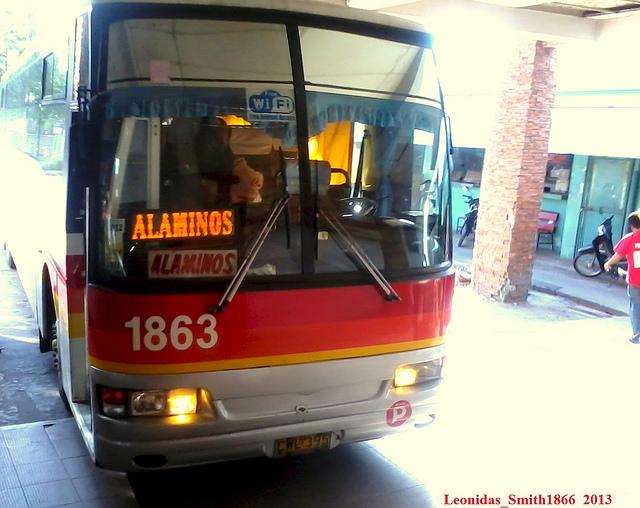What are the dimensions of the front two windows on the bus?
Keep it brief. 5" by 3". What are the numbers in red?
Be succinct. 1863. Is the language on the bus English?
Short answer required. No. What is the number on the bus?
Answer briefly. 1863. 